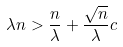Convert formula to latex. <formula><loc_0><loc_0><loc_500><loc_500>\lambda n > \frac { n } { \lambda } + \frac { \sqrt { n } } { \lambda } c</formula> 